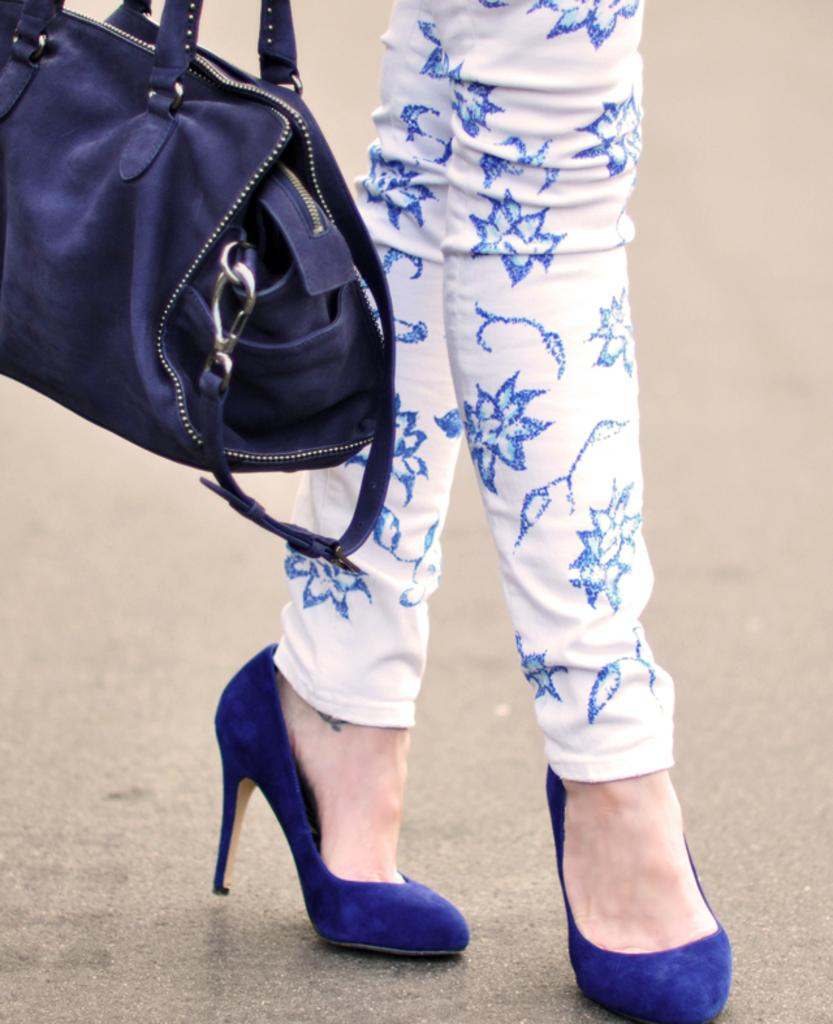Who is present in the image? There is a woman in the image. What is the woman wearing on her lower body? The woman is wearing white color trousers with a blue design. What color is the woman's handbag? The woman has a blue colored handbag. What type of footwear is the woman wearing? The woman is wearing blue colored heels. How many balls does the woman have in her hands in the image? There are no balls present in the image, and the woman's hands are not visible. 